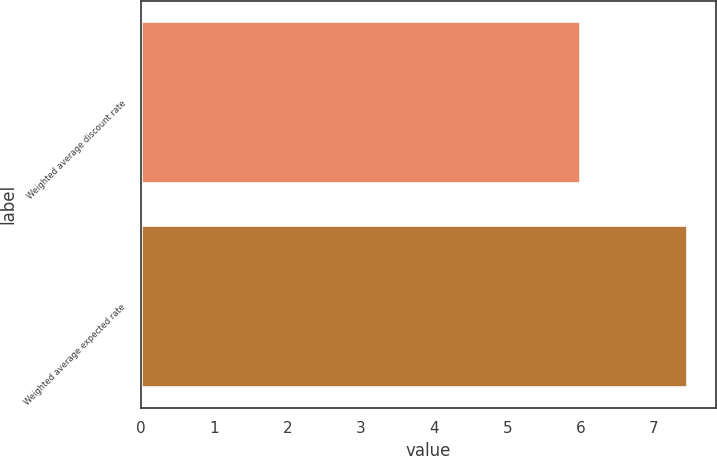<chart> <loc_0><loc_0><loc_500><loc_500><bar_chart><fcel>Weighted average discount rate<fcel>Weighted average expected rate<nl><fcel>6<fcel>7.47<nl></chart> 